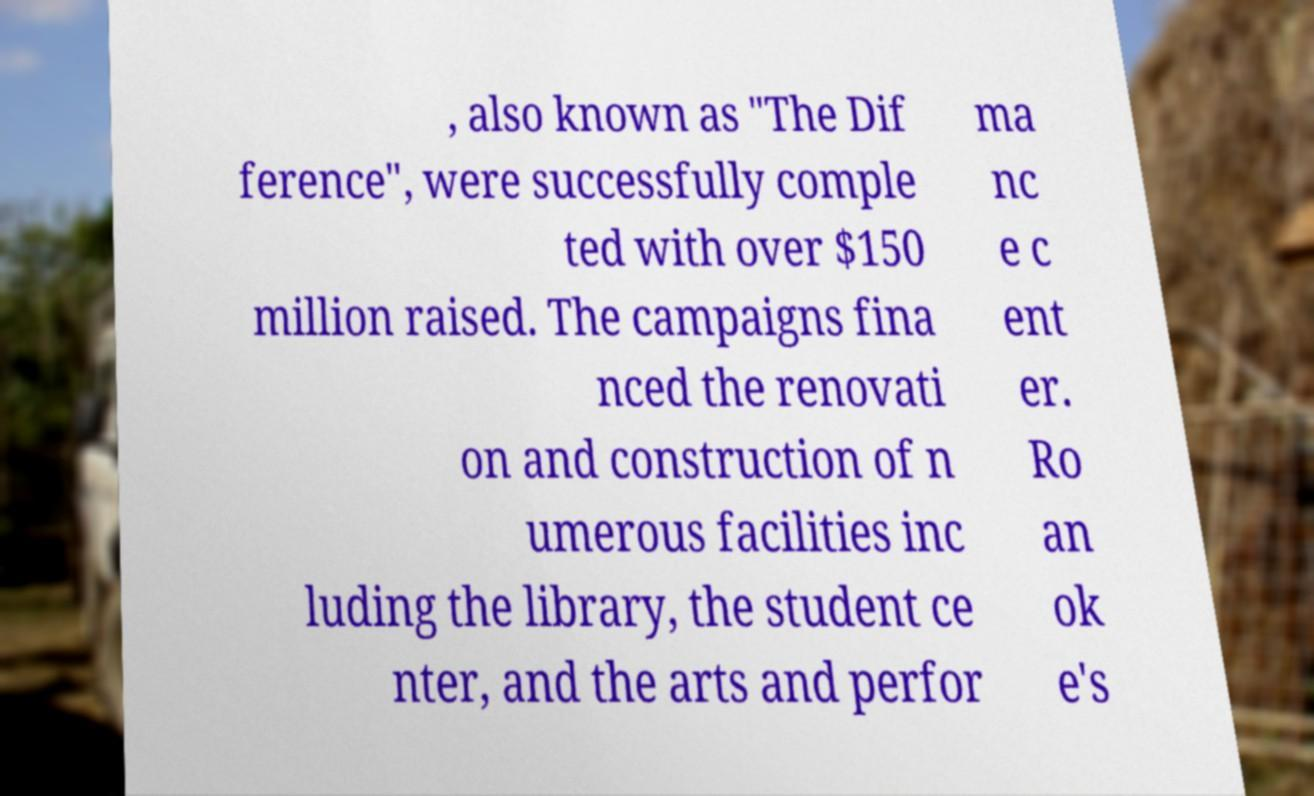For documentation purposes, I need the text within this image transcribed. Could you provide that? , also known as "The Dif ference", were successfully comple ted with over $150 million raised. The campaigns fina nced the renovati on and construction of n umerous facilities inc luding the library, the student ce nter, and the arts and perfor ma nc e c ent er. Ro an ok e's 